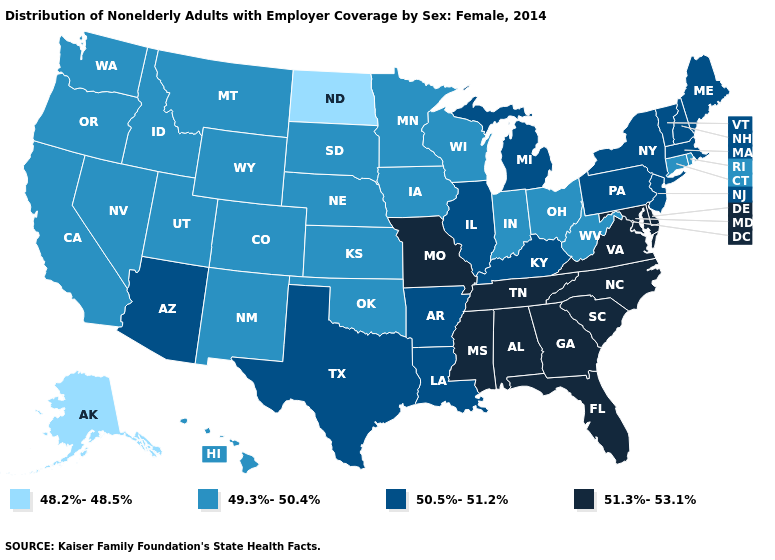Among the states that border Connecticut , does Rhode Island have the highest value?
Quick response, please. No. Does Massachusetts have the lowest value in the Northeast?
Concise answer only. No. Among the states that border Delaware , which have the lowest value?
Give a very brief answer. New Jersey, Pennsylvania. Does Georgia have the highest value in the South?
Concise answer only. Yes. Name the states that have a value in the range 49.3%-50.4%?
Concise answer only. California, Colorado, Connecticut, Hawaii, Idaho, Indiana, Iowa, Kansas, Minnesota, Montana, Nebraska, Nevada, New Mexico, Ohio, Oklahoma, Oregon, Rhode Island, South Dakota, Utah, Washington, West Virginia, Wisconsin, Wyoming. Does Oklahoma have the lowest value in the South?
Concise answer only. Yes. Does North Dakota have the lowest value in the MidWest?
Answer briefly. Yes. Which states have the lowest value in the USA?
Give a very brief answer. Alaska, North Dakota. Is the legend a continuous bar?
Concise answer only. No. Among the states that border Texas , does Oklahoma have the lowest value?
Concise answer only. Yes. What is the lowest value in the South?
Quick response, please. 49.3%-50.4%. Among the states that border Connecticut , which have the lowest value?
Short answer required. Rhode Island. Name the states that have a value in the range 49.3%-50.4%?
Quick response, please. California, Colorado, Connecticut, Hawaii, Idaho, Indiana, Iowa, Kansas, Minnesota, Montana, Nebraska, Nevada, New Mexico, Ohio, Oklahoma, Oregon, Rhode Island, South Dakota, Utah, Washington, West Virginia, Wisconsin, Wyoming. Which states have the lowest value in the USA?
Quick response, please. Alaska, North Dakota. What is the value of Texas?
Write a very short answer. 50.5%-51.2%. 